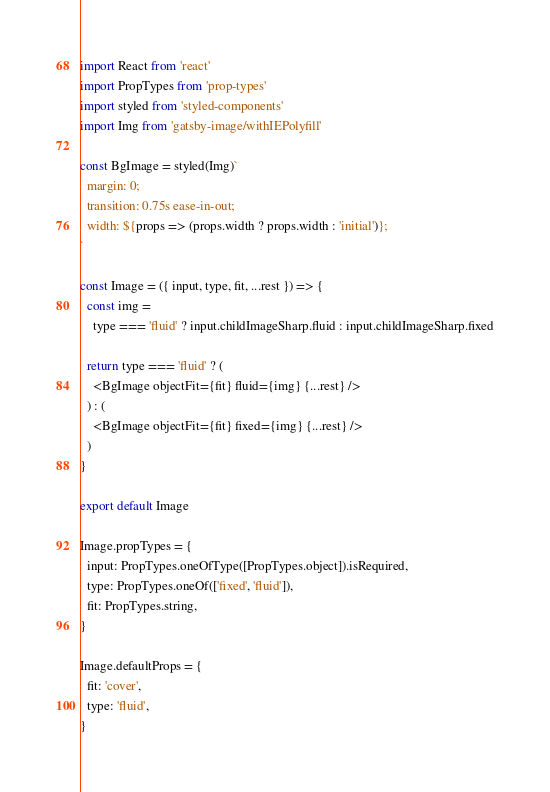<code> <loc_0><loc_0><loc_500><loc_500><_JavaScript_>import React from 'react'
import PropTypes from 'prop-types'
import styled from 'styled-components'
import Img from 'gatsby-image/withIEPolyfill'

const BgImage = styled(Img)`
  margin: 0;
  transition: 0.75s ease-in-out;
  width: ${props => (props.width ? props.width : 'initial')};
`

const Image = ({ input, type, fit, ...rest }) => {
  const img =
    type === 'fluid' ? input.childImageSharp.fluid : input.childImageSharp.fixed

  return type === 'fluid' ? (
    <BgImage objectFit={fit} fluid={img} {...rest} />
  ) : (
    <BgImage objectFit={fit} fixed={img} {...rest} />
  )
}

export default Image

Image.propTypes = {
  input: PropTypes.oneOfType([PropTypes.object]).isRequired,
  type: PropTypes.oneOf(['fixed', 'fluid']),
  fit: PropTypes.string,
}

Image.defaultProps = {
  fit: 'cover',
  type: 'fluid',
}
</code> 